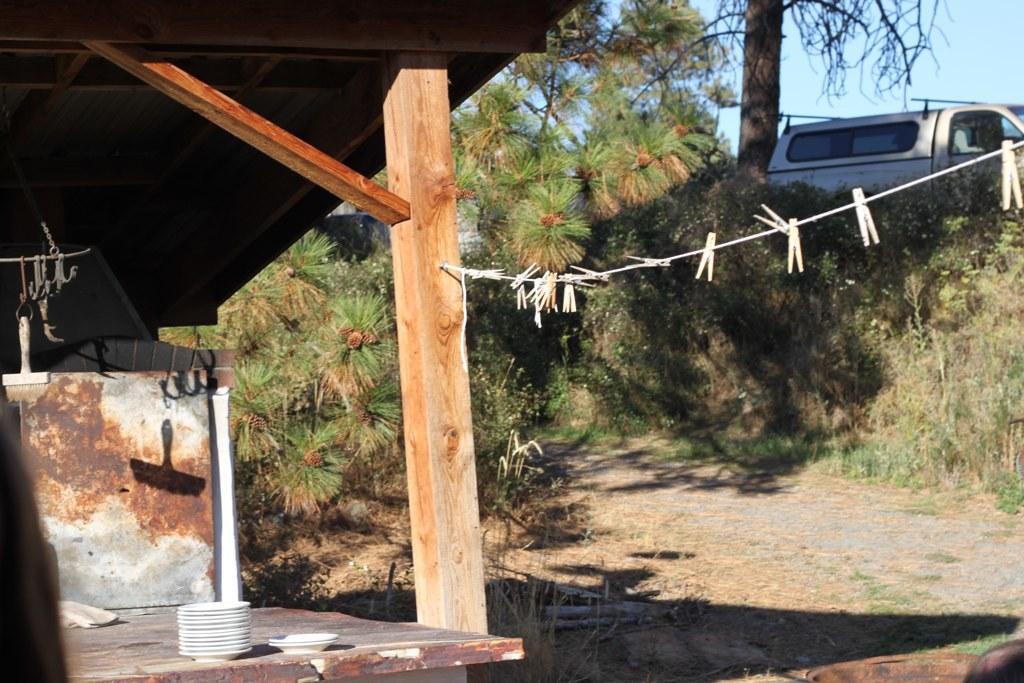Please provide a concise description of this image. In this image, we can see trees and plants. There is a shelter on the left side of the image. There are plates in the bottom left of the image. There is a stem and vehicle in the top right of the image. There is a rope in the middle of the image contains clips. 